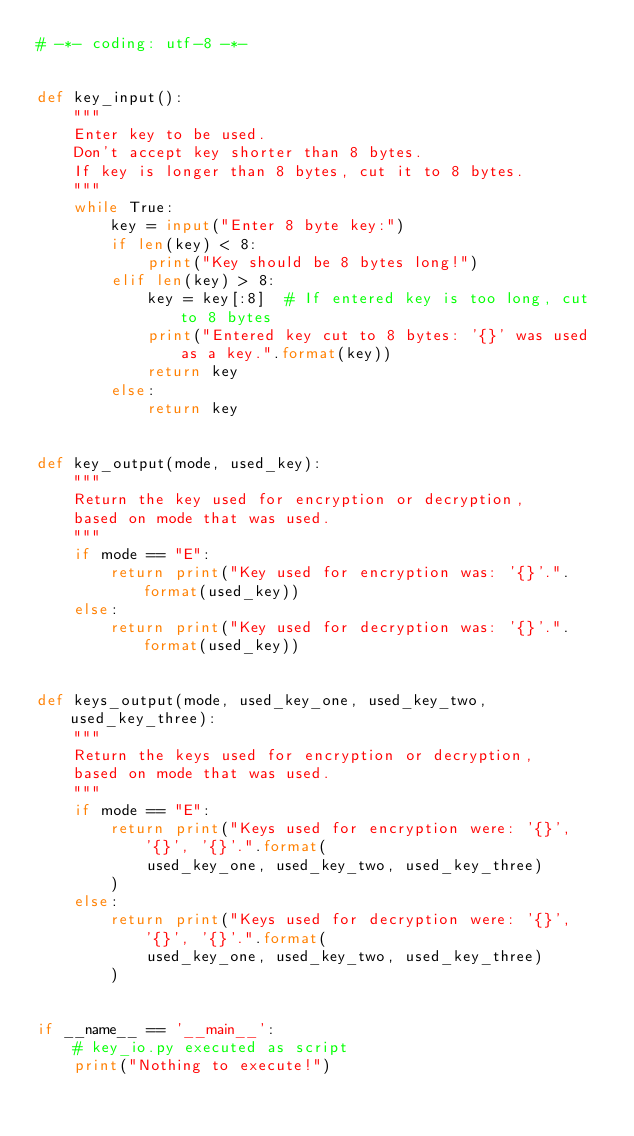<code> <loc_0><loc_0><loc_500><loc_500><_Python_># -*- coding: utf-8 -*-


def key_input():
    """
    Enter key to be used.
    Don't accept key shorter than 8 bytes.
    If key is longer than 8 bytes, cut it to 8 bytes.
    """
    while True:
        key = input("Enter 8 byte key:")
        if len(key) < 8:
            print("Key should be 8 bytes long!")
        elif len(key) > 8:
            key = key[:8]  # If entered key is too long, cut to 8 bytes
            print("Entered key cut to 8 bytes: '{}' was used as a key.".format(key))
            return key
        else:
            return key


def key_output(mode, used_key):
    """
    Return the key used for encryption or decryption,
    based on mode that was used.
    """
    if mode == "E":
        return print("Key used for encryption was: '{}'.".format(used_key))
    else:
        return print("Key used for decryption was: '{}'.".format(used_key))


def keys_output(mode, used_key_one, used_key_two, used_key_three):
    """
    Return the keys used for encryption or decryption,
    based on mode that was used.
    """
    if mode == "E":
        return print("Keys used for encryption were: '{}', '{}', '{}'.".format(
            used_key_one, used_key_two, used_key_three)
        )
    else:
        return print("Keys used for decryption were: '{}', '{}', '{}'.".format(
            used_key_one, used_key_two, used_key_three)
        )


if __name__ == '__main__':
    # key_io.py executed as script
    print("Nothing to execute!")</code> 